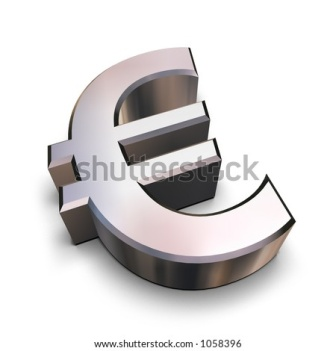What do you think is going on in this snapshot? The image depicts a 3D illustration of the Euro currency symbol (€). The symbol, rendered in a shiny metallic silver, features three horizontal bars intersected by a curved vertical bar, contributing to its iconic design. The vertical bar, darker in contrast to the horizontal bars, enhances the visual depth. Slightly tilted to the right, the symbol casts a realistic shadow on the white background, suggesting a light source originating from the left. This tilt, combined with the shadow, imparts a sense of motion and dimension. A subtle black outline around the bars further distinguishes the symbol, emphasizing its prominence against an otherwise minimalist backdrop. The succinct and focused representation clearly highlights the Euro sign's importance, free from any additional elements or text. 